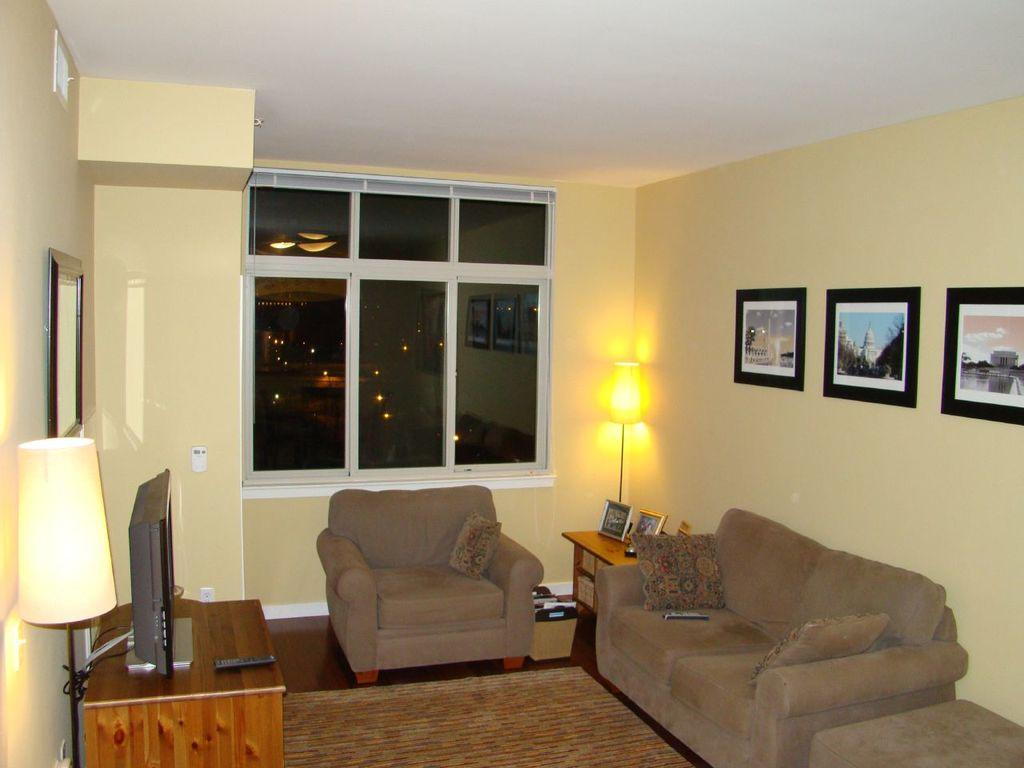What type of furniture is in the image? There is a sofa in the image. What type of electronic device is in the image? There is a television in the image. What object is used for controlling the television? A remote is present on a table in the image. What type of lighting is in the image? There is a lamp in the image. What architectural feature is in the image? There is a window in the image. What decorative item is on the wall in the background of the image? There is a photo frame on the wall in the background of the image. How many rabbits can be seen playing in the seashore in the image? There are no rabbits or seashore present in the image. What type of parent is sitting on the sofa in the image? There is no parent or indication of a parent sitting on the sofa in the image. 